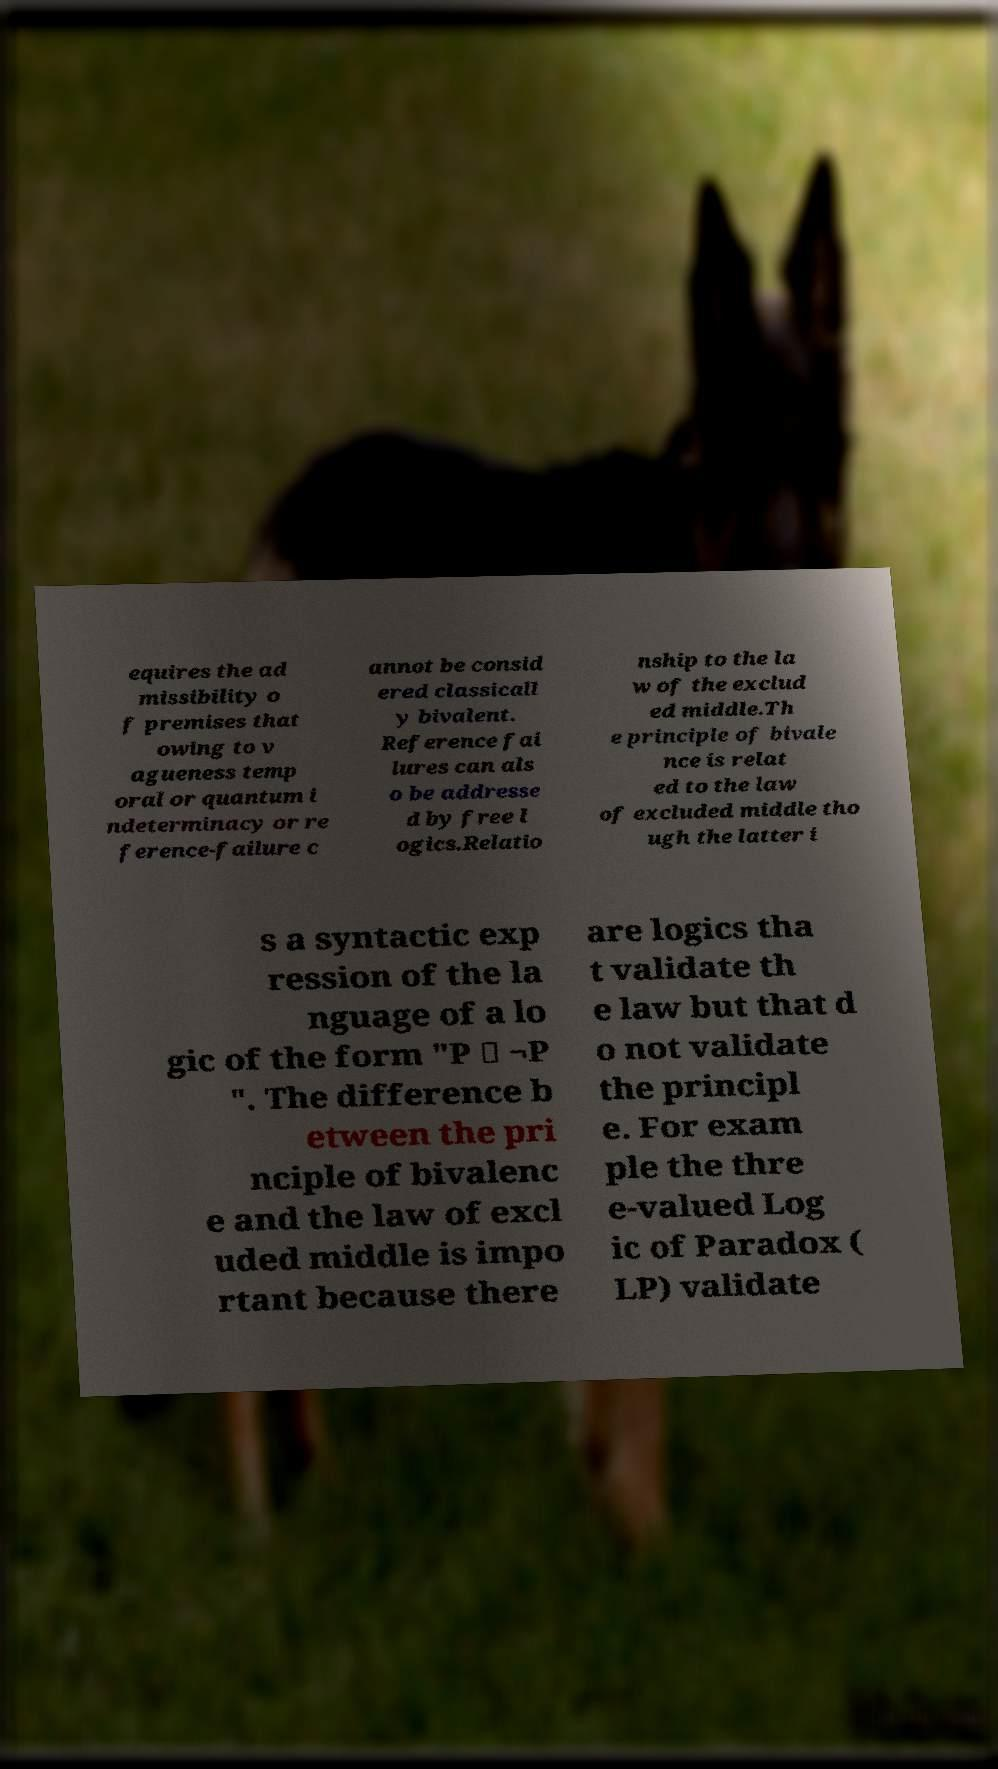Please identify and transcribe the text found in this image. equires the ad missibility o f premises that owing to v agueness temp oral or quantum i ndeterminacy or re ference-failure c annot be consid ered classicall y bivalent. Reference fai lures can als o be addresse d by free l ogics.Relatio nship to the la w of the exclud ed middle.Th e principle of bivale nce is relat ed to the law of excluded middle tho ugh the latter i s a syntactic exp ression of the la nguage of a lo gic of the form "P ∨ ¬P ". The difference b etween the pri nciple of bivalenc e and the law of excl uded middle is impo rtant because there are logics tha t validate th e law but that d o not validate the principl e. For exam ple the thre e-valued Log ic of Paradox ( LP) validate 